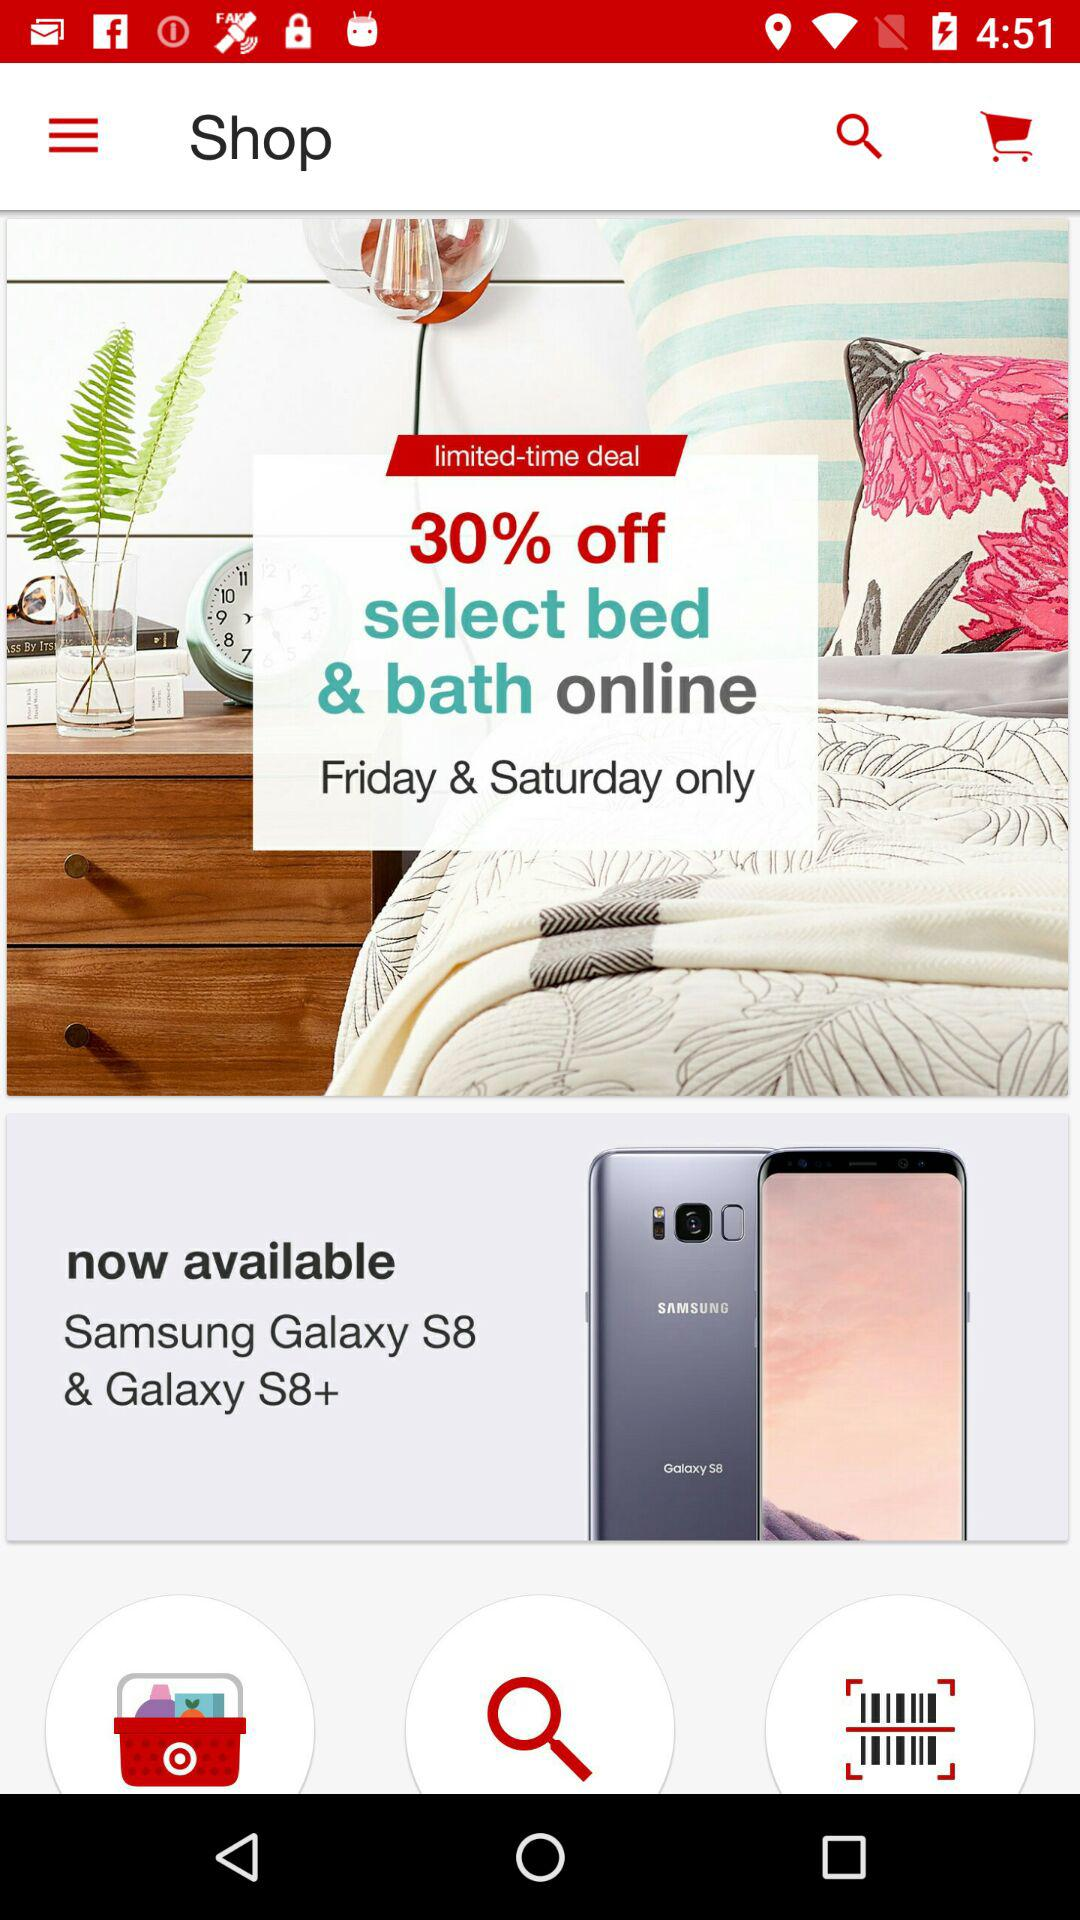How much of a percentage discount is given on "select bed & bath online"? The discount is 30%. 